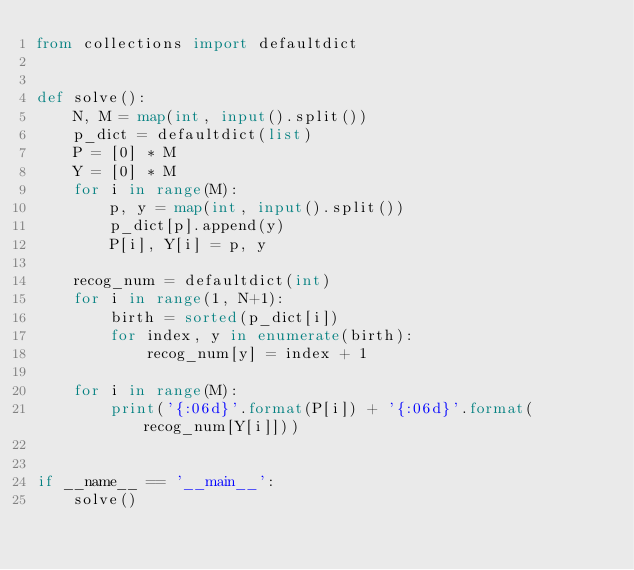<code> <loc_0><loc_0><loc_500><loc_500><_Python_>from collections import defaultdict


def solve():
    N, M = map(int, input().split())
    p_dict = defaultdict(list)
    P = [0] * M
    Y = [0] * M
    for i in range(M):
        p, y = map(int, input().split())
        p_dict[p].append(y)
        P[i], Y[i] = p, y
    
    recog_num = defaultdict(int)
    for i in range(1, N+1):
        birth = sorted(p_dict[i])
        for index, y in enumerate(birth):
            recog_num[y] = index + 1
    
    for i in range(M):
        print('{:06d}'.format(P[i]) + '{:06d}'.format(recog_num[Y[i]]))


if __name__ == '__main__':
    solve()
</code> 